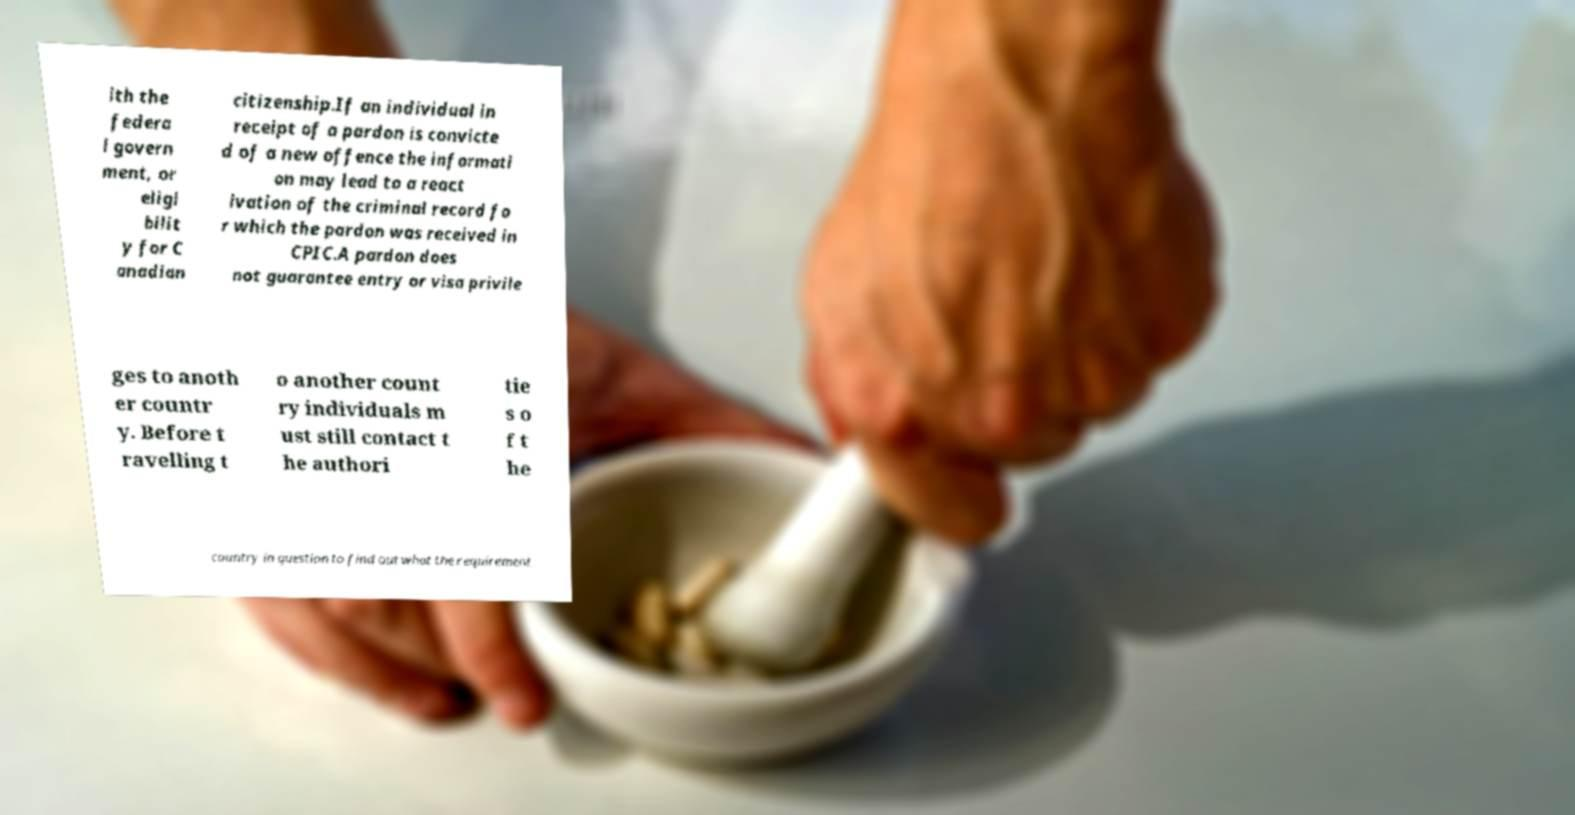I need the written content from this picture converted into text. Can you do that? ith the federa l govern ment, or eligi bilit y for C anadian citizenship.If an individual in receipt of a pardon is convicte d of a new offence the informati on may lead to a react ivation of the criminal record fo r which the pardon was received in CPIC.A pardon does not guarantee entry or visa privile ges to anoth er countr y. Before t ravelling t o another count ry individuals m ust still contact t he authori tie s o f t he country in question to find out what the requirement 